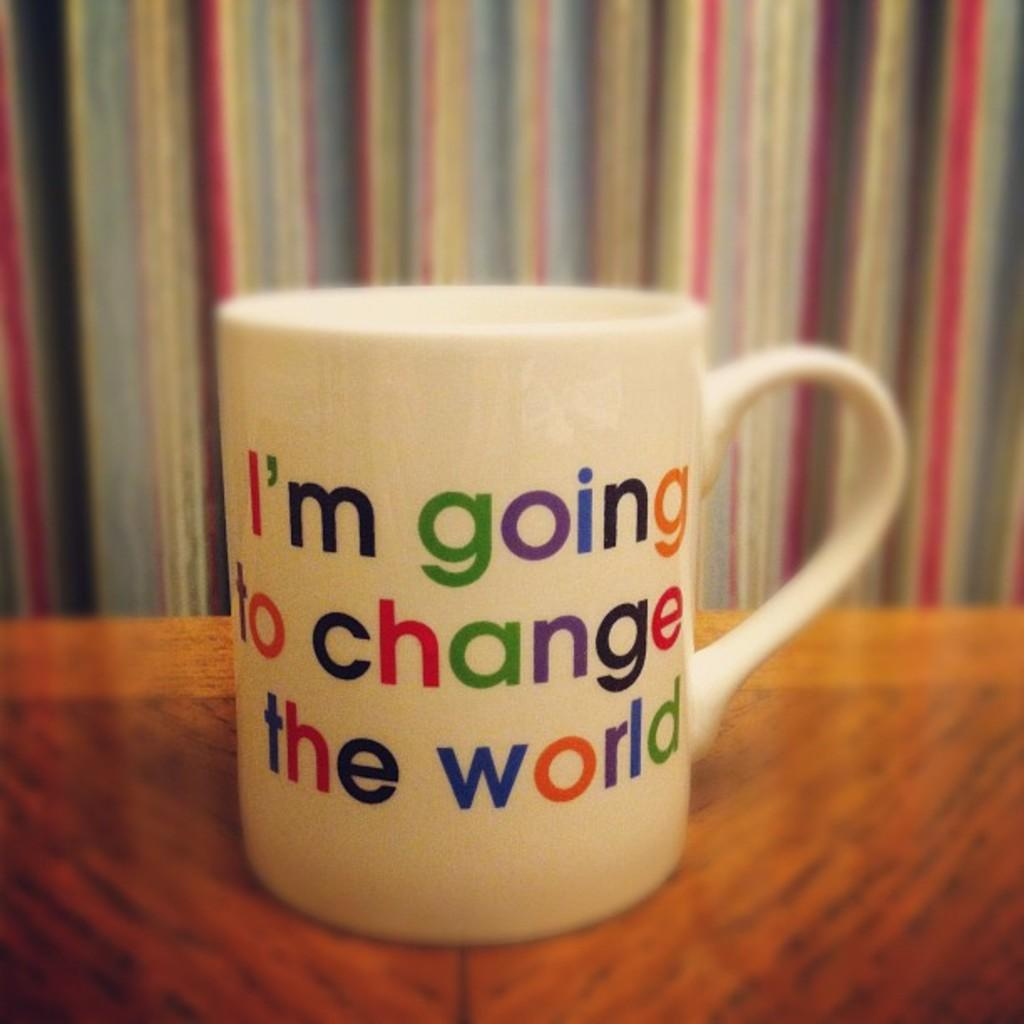<image>
Give a short and clear explanation of the subsequent image. A mug that says I'm going to change the world 